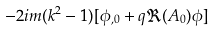<formula> <loc_0><loc_0><loc_500><loc_500>- 2 i m ( k ^ { 2 } - 1 ) [ \phi _ { , 0 } + q \Re ( A _ { 0 } ) \phi ]</formula> 